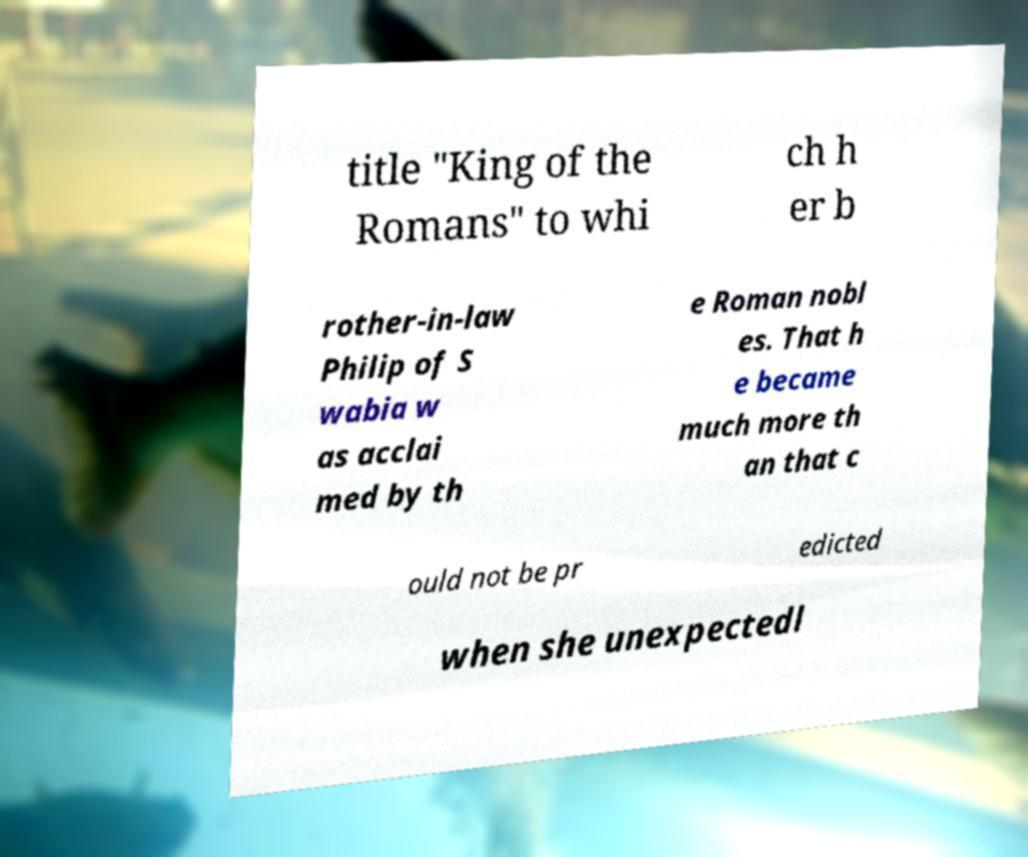Can you accurately transcribe the text from the provided image for me? title "King of the Romans" to whi ch h er b rother-in-law Philip of S wabia w as acclai med by th e Roman nobl es. That h e became much more th an that c ould not be pr edicted when she unexpectedl 